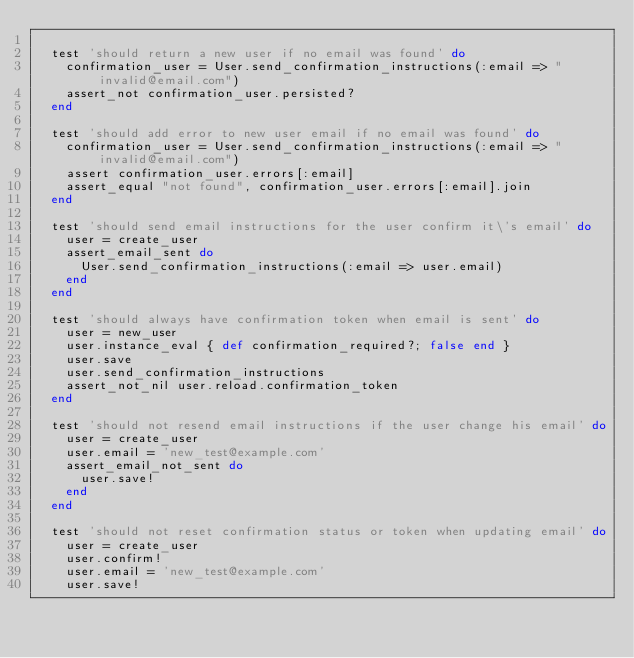<code> <loc_0><loc_0><loc_500><loc_500><_Ruby_>
  test 'should return a new user if no email was found' do
    confirmation_user = User.send_confirmation_instructions(:email => "invalid@email.com")
    assert_not confirmation_user.persisted?
  end

  test 'should add error to new user email if no email was found' do
    confirmation_user = User.send_confirmation_instructions(:email => "invalid@email.com")
    assert confirmation_user.errors[:email]
    assert_equal "not found", confirmation_user.errors[:email].join
  end

  test 'should send email instructions for the user confirm it\'s email' do
    user = create_user
    assert_email_sent do
      User.send_confirmation_instructions(:email => user.email)
    end
  end
  
  test 'should always have confirmation token when email is sent' do
    user = new_user
    user.instance_eval { def confirmation_required?; false end }
    user.save
    user.send_confirmation_instructions
    assert_not_nil user.reload.confirmation_token
  end

  test 'should not resend email instructions if the user change his email' do
    user = create_user
    user.email = 'new_test@example.com'
    assert_email_not_sent do
      user.save!
    end
  end

  test 'should not reset confirmation status or token when updating email' do
    user = create_user
    user.confirm!
    user.email = 'new_test@example.com'
    user.save!
</code> 